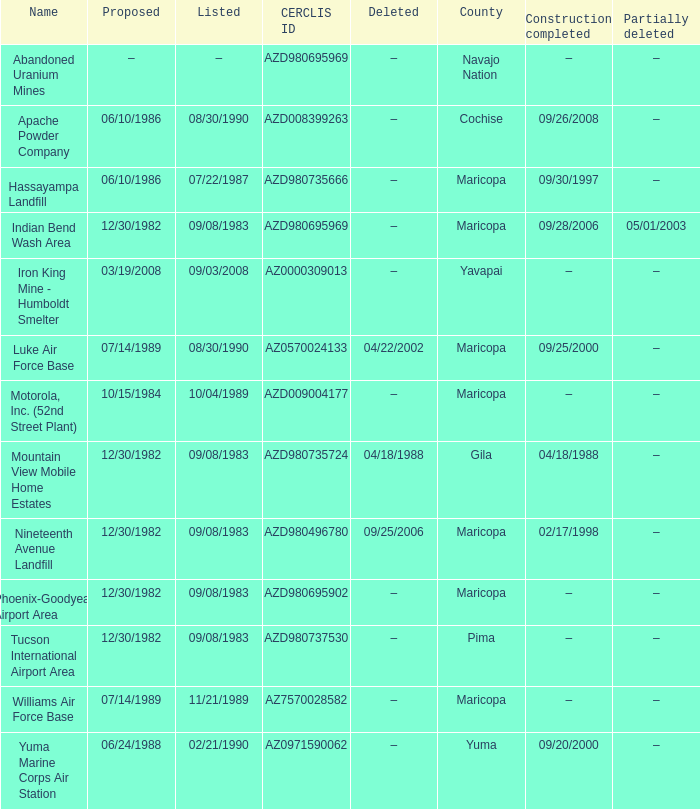What is the cerclis id when the site was proposed on 12/30/1982 and was partially deleted on 05/01/2003? AZD980695969. 